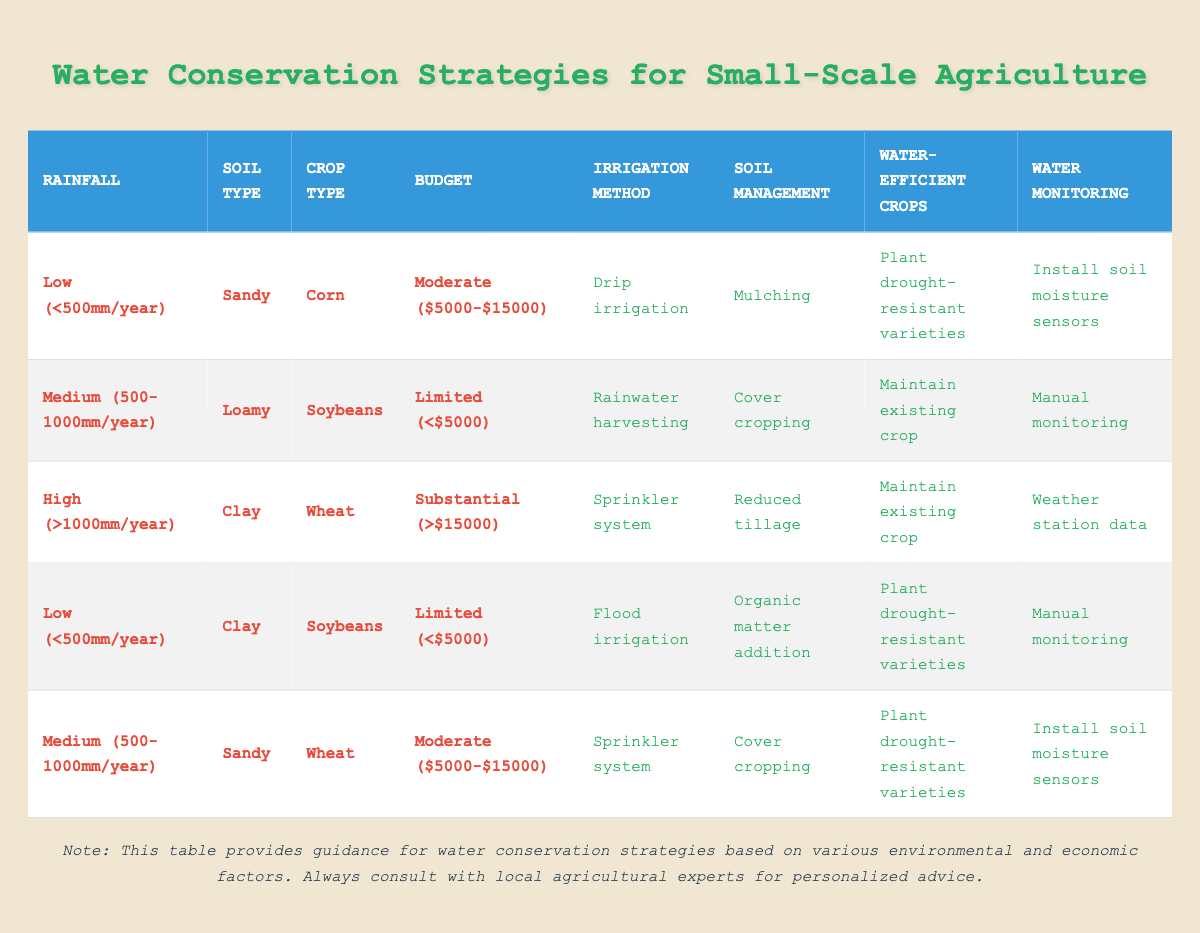What irrigation method is recommended for sandy soil with low rainfall and a moderate budget? By looking at the table, the conditions that match sandy soil with low rainfall (<500mm/year) and a moderate budget ($5000-$15000) indicate that the recommended irrigation method is drip irrigation.
Answer: Drip irrigation Is the recommendation for soil management the same for loamy soil with medium rainfall and a limited budget, compared to sandy soil with medium rainfall and a moderate budget? For loamy soil with medium rainfall (500-1000mm/year) and a limited budget (<$5000), the recommendation is cover cropping. For sandy soil with medium rainfall (500-1000mm/year) and a moderate budget ($5000-$15000), the recommendation is also cover cropping. Thus, the recommendations are the same.
Answer: Yes What is the irrigation method used for clay soil crops if the rainfall is high and the budget is substantial? Referring to the table, when the conditions specify clay soil, high rainfall (>1000mm/year), and a substantial budget (>$15000), the irrigation method specified is a sprinkler system.
Answer: Sprinkler system How many different irrigation methods are suggested in total? The table lists four different irrigation methods, which are drip irrigation, sprinkler system, flood irrigation, and rainwater harvesting. Therefore, the total is four different methods suggested.
Answer: 4 For crops in sandy soil receiving medium rainfall and with a moderate budget, what two strategies are recommended for soil management and water monitoring? Looking at sandy soil with medium rainfall (500-1000mm/year) and a moderate budget ($5000-$15000), the table suggests the soil management strategy of cover cropping and for water monitoring, the recommended action is to install soil moisture sensors.
Answer: Cover cropping, Install soil moisture sensors If a farmer has a substantial budget but low rainfall and is growing soybeans, what irrigation method is recommended? According to the table, for a farmer growing soybeans in low rainfall (<500mm/year) with a substantial budget (>$15000), the recommended irrigation method is not listed. Hence, there's no applicable recommendation for this specific scenario in the table.
Answer: No recommendation available What is the most effective water-efficient crop strategy for clay soil receiving low rainfall and where the budget is limited? The table shows that for clay soil under low rainfall conditions (<500mm/year) and a limited budget (<$5000), the effective strategy for water-efficient crops is to plant drought-resistant varieties.
Answer: Plant drought-resistant varieties What type of monitoring is suggested for a farmer with sandy soil and a limited budget but medium rainfall? The conditions specify a limited budget (<$5000) for sandy soil with medium rainfall (500-1000mm/year), where manual monitoring is the suggested action for water monitoring in this case.
Answer: Manual monitoring 